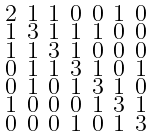<formula> <loc_0><loc_0><loc_500><loc_500>\begin{smallmatrix} 2 & 1 & 1 & 0 & 0 & 1 & 0 \\ 1 & 3 & 1 & 1 & 1 & 0 & 0 \\ 1 & 1 & 3 & 1 & 0 & 0 & 0 \\ 0 & 1 & 1 & 3 & 1 & 0 & 1 \\ 0 & 1 & 0 & 1 & 3 & 1 & 0 \\ 1 & 0 & 0 & 0 & 1 & 3 & 1 \\ 0 & 0 & 0 & 1 & 0 & 1 & 3 \end{smallmatrix}</formula> 